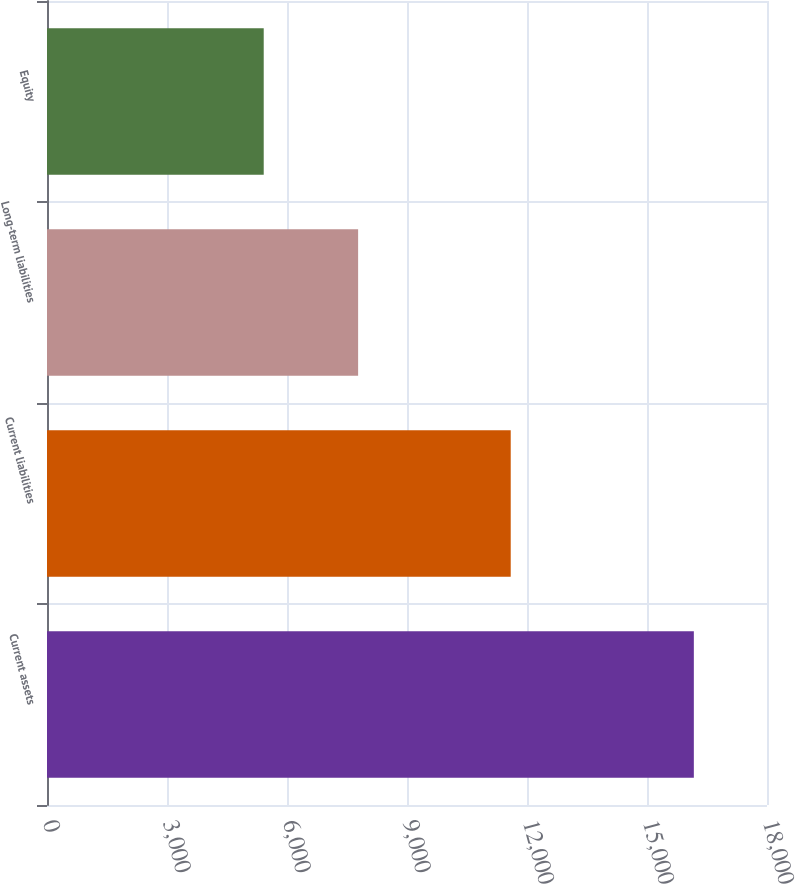Convert chart to OTSL. <chart><loc_0><loc_0><loc_500><loc_500><bar_chart><fcel>Current assets<fcel>Current liabilities<fcel>Long-term liabilities<fcel>Equity<nl><fcel>16171<fcel>11593<fcel>7778<fcel>5418<nl></chart> 